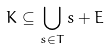<formula> <loc_0><loc_0><loc_500><loc_500>K \subseteq \bigcup _ { s \in T } s + E</formula> 